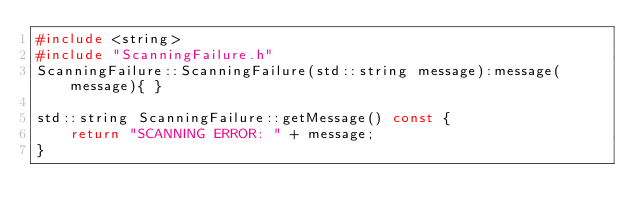<code> <loc_0><loc_0><loc_500><loc_500><_C++_>#include <string>
#include "ScanningFailure.h"
ScanningFailure::ScanningFailure(std::string message):message(message){ }

std::string ScanningFailure::getMessage() const {
    return "SCANNING ERROR: " + message;
}
</code> 